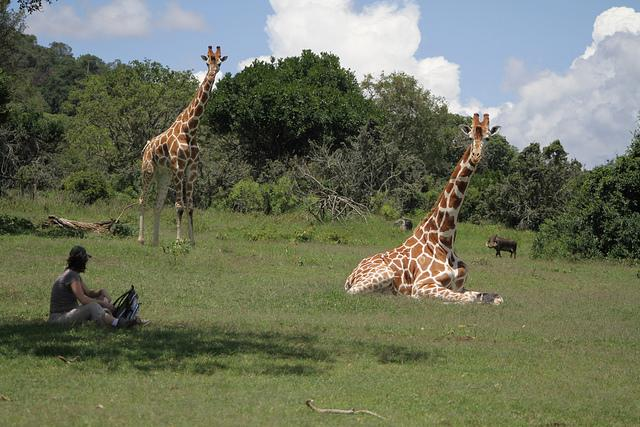Where is the person in? Please explain your reasoning. wilderness. The person is sitting with the wild animals which makes it seem like its in the wilderness since there is no enclosure. 